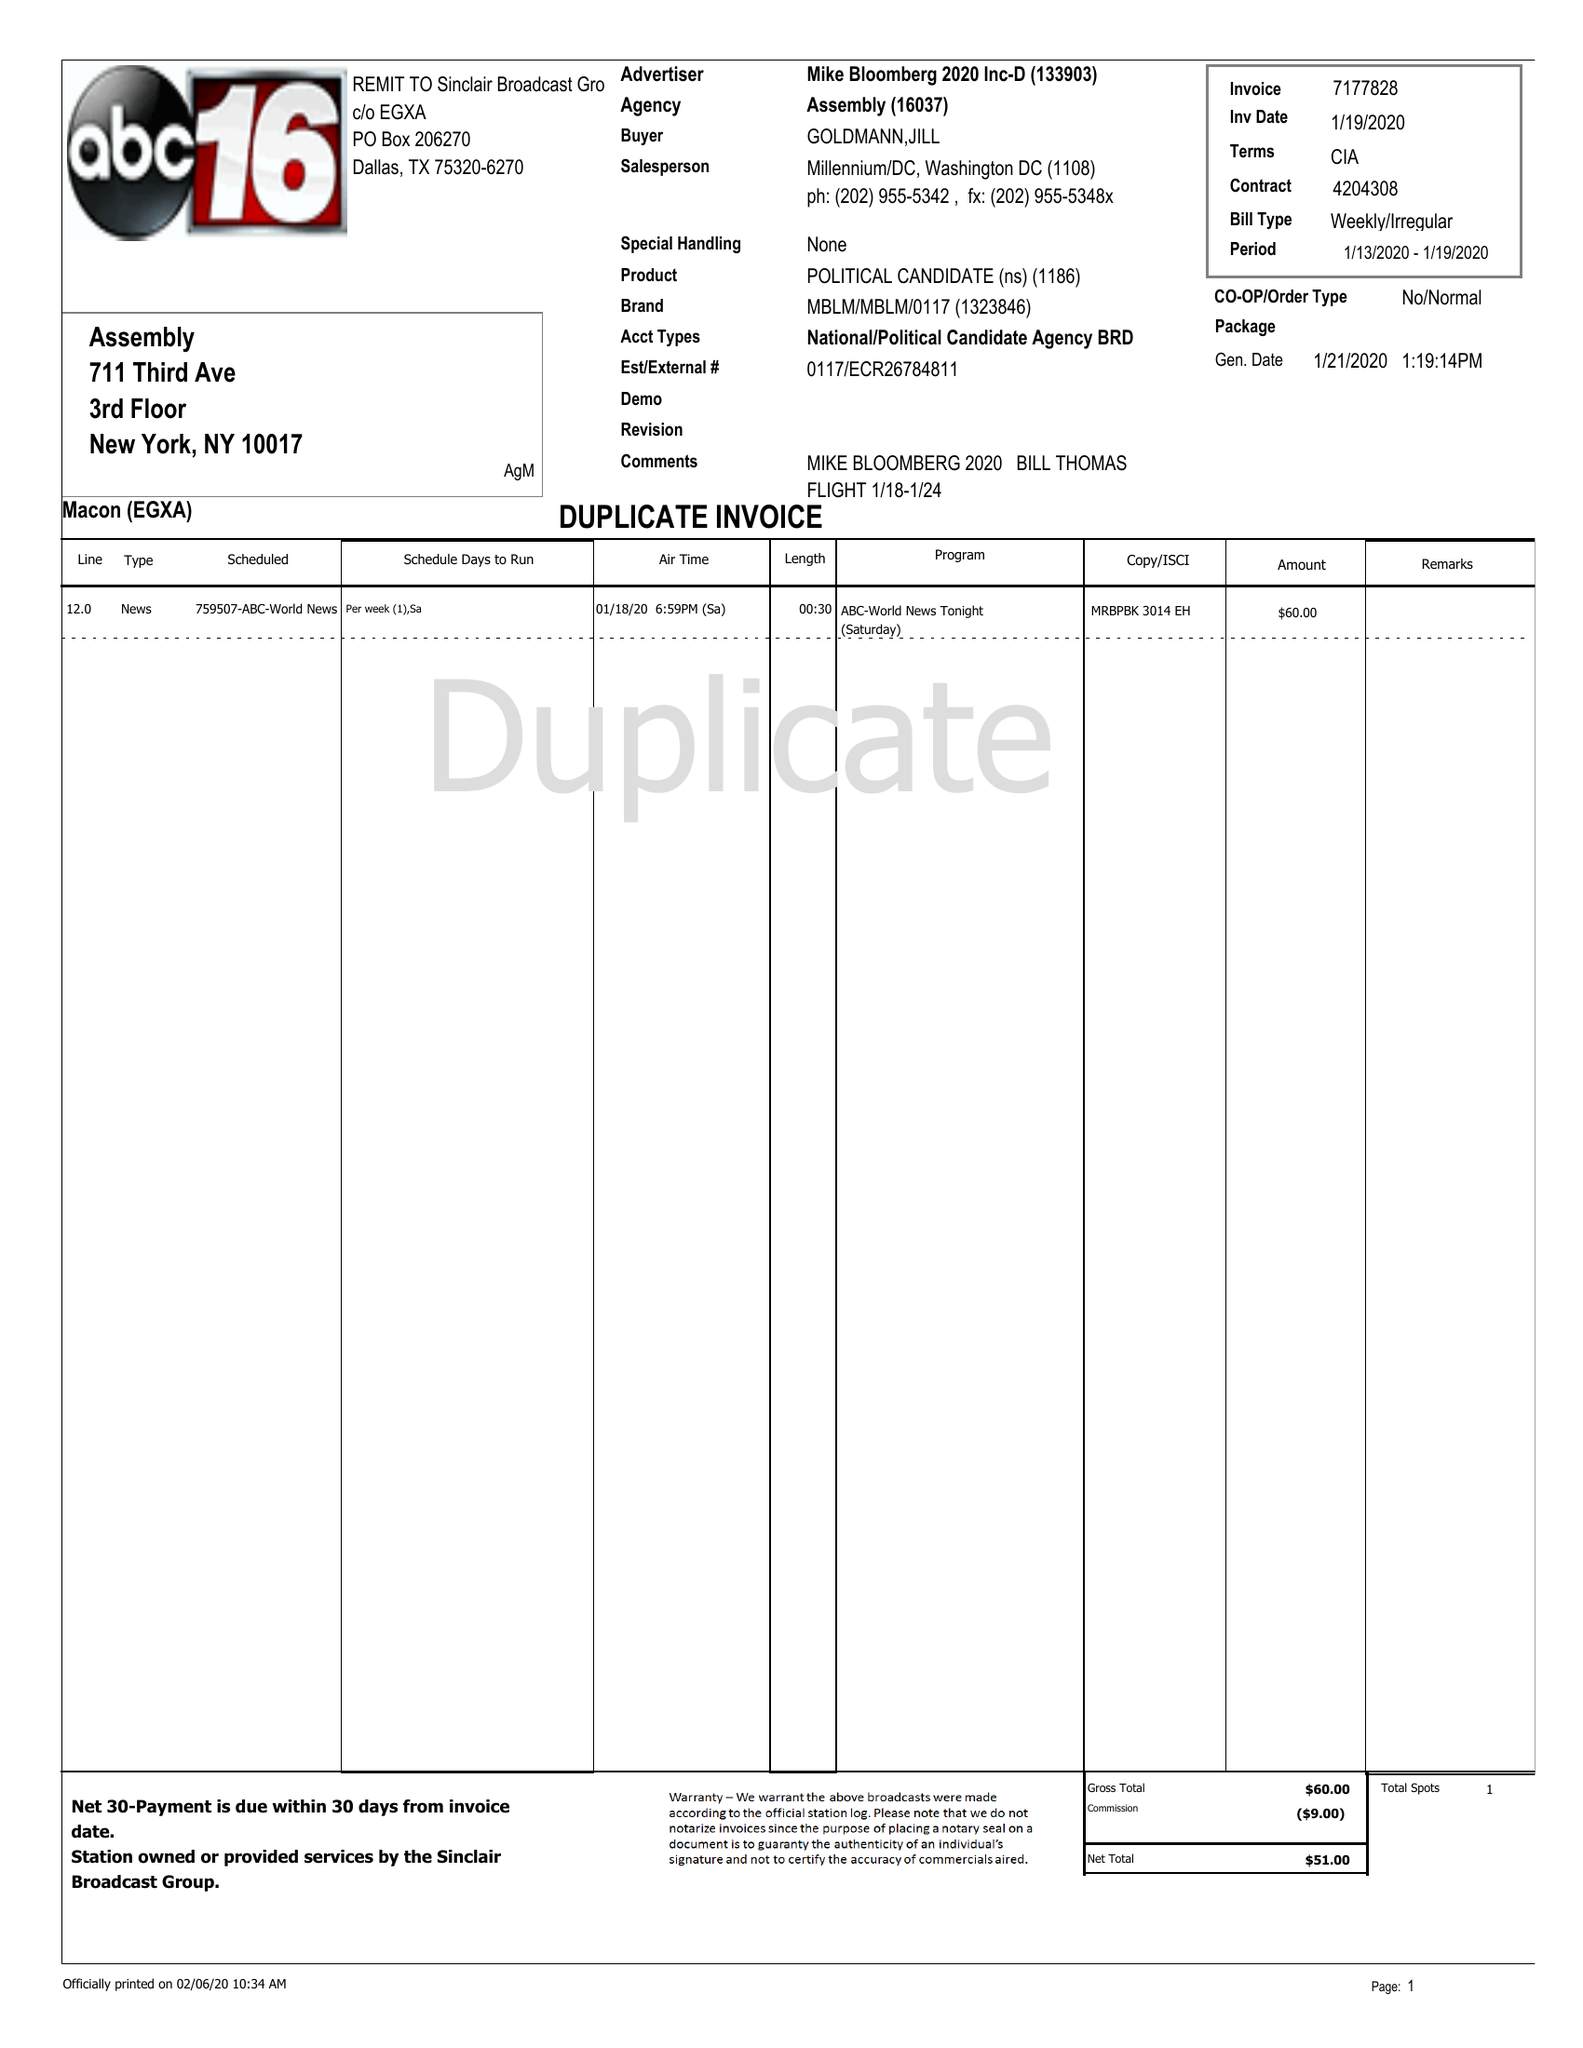What is the value for the flight_from?
Answer the question using a single word or phrase. 01/13/20 